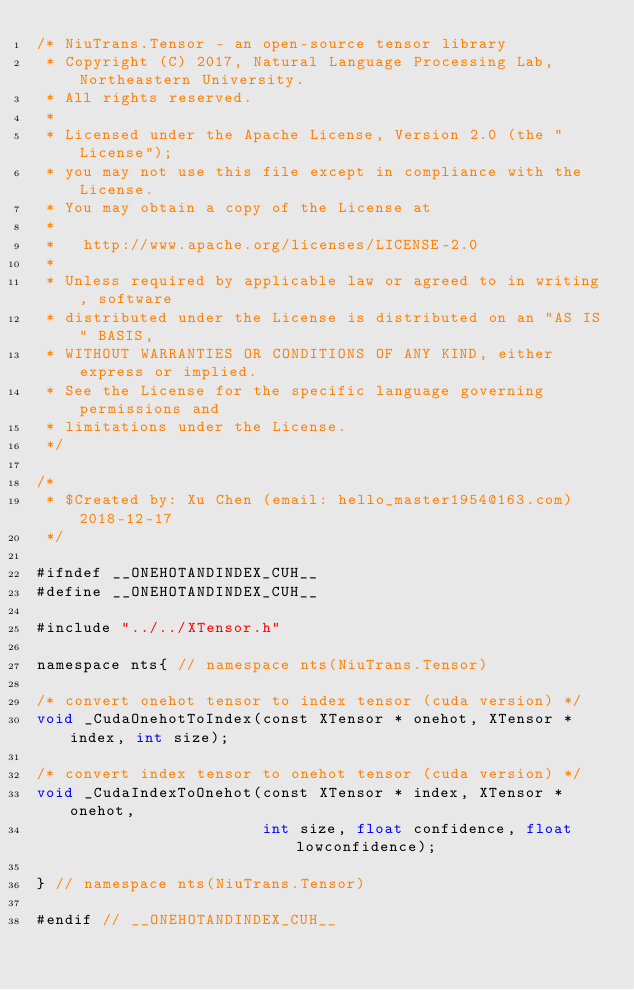Convert code to text. <code><loc_0><loc_0><loc_500><loc_500><_Cuda_>/* NiuTrans.Tensor - an open-source tensor library
 * Copyright (C) 2017, Natural Language Processing Lab, Northeastern University.
 * All rights reserved.
 *
 * Licensed under the Apache License, Version 2.0 (the "License");
 * you may not use this file except in compliance with the License.
 * You may obtain a copy of the License at
 *
 *   http://www.apache.org/licenses/LICENSE-2.0
 *
 * Unless required by applicable law or agreed to in writing, software
 * distributed under the License is distributed on an "AS IS" BASIS,
 * WITHOUT WARRANTIES OR CONDITIONS OF ANY KIND, either express or implied.
 * See the License for the specific language governing permissions and
 * limitations under the License.
 */

/*
 * $Created by: Xu Chen (email: hello_master1954@163.com) 2018-12-17
 */

#ifndef __ONEHOTANDINDEX_CUH__
#define __ONEHOTANDINDEX_CUH__

#include "../../XTensor.h"

namespace nts{ // namespace nts(NiuTrans.Tensor)

/* convert onehot tensor to index tensor (cuda version) */
void _CudaOnehotToIndex(const XTensor * onehot, XTensor * index, int size);

/* convert index tensor to onehot tensor (cuda version) */
void _CudaIndexToOnehot(const XTensor * index, XTensor * onehot, 
                        int size, float confidence, float lowconfidence);

} // namespace nts(NiuTrans.Tensor)

#endif // __ONEHOTANDINDEX_CUH__</code> 